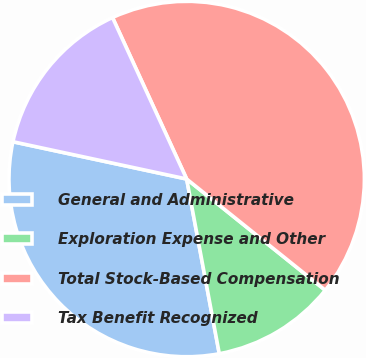<chart> <loc_0><loc_0><loc_500><loc_500><pie_chart><fcel>General and Administrative<fcel>Exploration Expense and Other<fcel>Total Stock-Based Compensation<fcel>Tax Benefit Recognized<nl><fcel>31.3%<fcel>11.3%<fcel>42.61%<fcel>14.78%<nl></chart> 